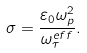Convert formula to latex. <formula><loc_0><loc_0><loc_500><loc_500>\sigma = \frac { \varepsilon _ { 0 } \omega _ { p } ^ { 2 } } { \omega _ { \tau } ^ { e f f } } .</formula> 